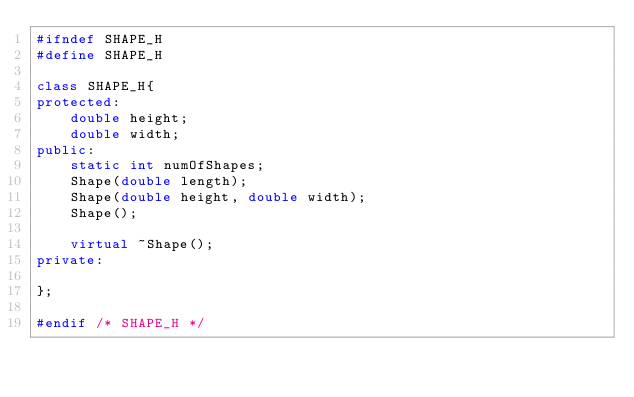<code> <loc_0><loc_0><loc_500><loc_500><_C++_>#ifndef SHAPE_H
#define SHAPE_H

class SHAPE_H{
protected:
    double height;
    double width;
public:
    static int numOfShapes;
    Shape(double length);
    Shape(double height, double width);
    Shape();

    virtual ~Shape();
private:

};

#endif /* SHAPE_H */</code> 